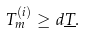Convert formula to latex. <formula><loc_0><loc_0><loc_500><loc_500>T _ { m } ^ { ( i ) } \geq d \underline { T } .</formula> 